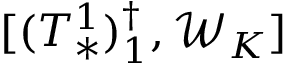Convert formula to latex. <formula><loc_0><loc_0><loc_500><loc_500>[ ( T _ { * } ^ { 1 } ) _ { 1 } ^ { \dag } , \mathcal { W } _ { K } ]</formula> 